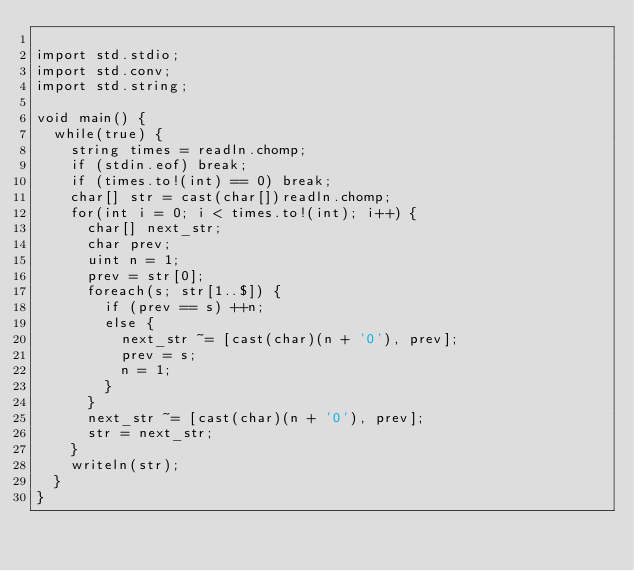<code> <loc_0><loc_0><loc_500><loc_500><_D_>
import std.stdio;
import std.conv;
import std.string;

void main() {
  while(true) {
    string times = readln.chomp;
    if (stdin.eof) break;
    if (times.to!(int) == 0) break;
    char[] str = cast(char[])readln.chomp;
    for(int i = 0; i < times.to!(int); i++) {
      char[] next_str;
      char prev;
      uint n = 1;
      prev = str[0];
      foreach(s; str[1..$]) {
        if (prev == s) ++n;
        else {
          next_str ~= [cast(char)(n + '0'), prev];
          prev = s;
          n = 1;
        }
      }
      next_str ~= [cast(char)(n + '0'), prev];
      str = next_str;
    }
    writeln(str);
  }
}</code> 